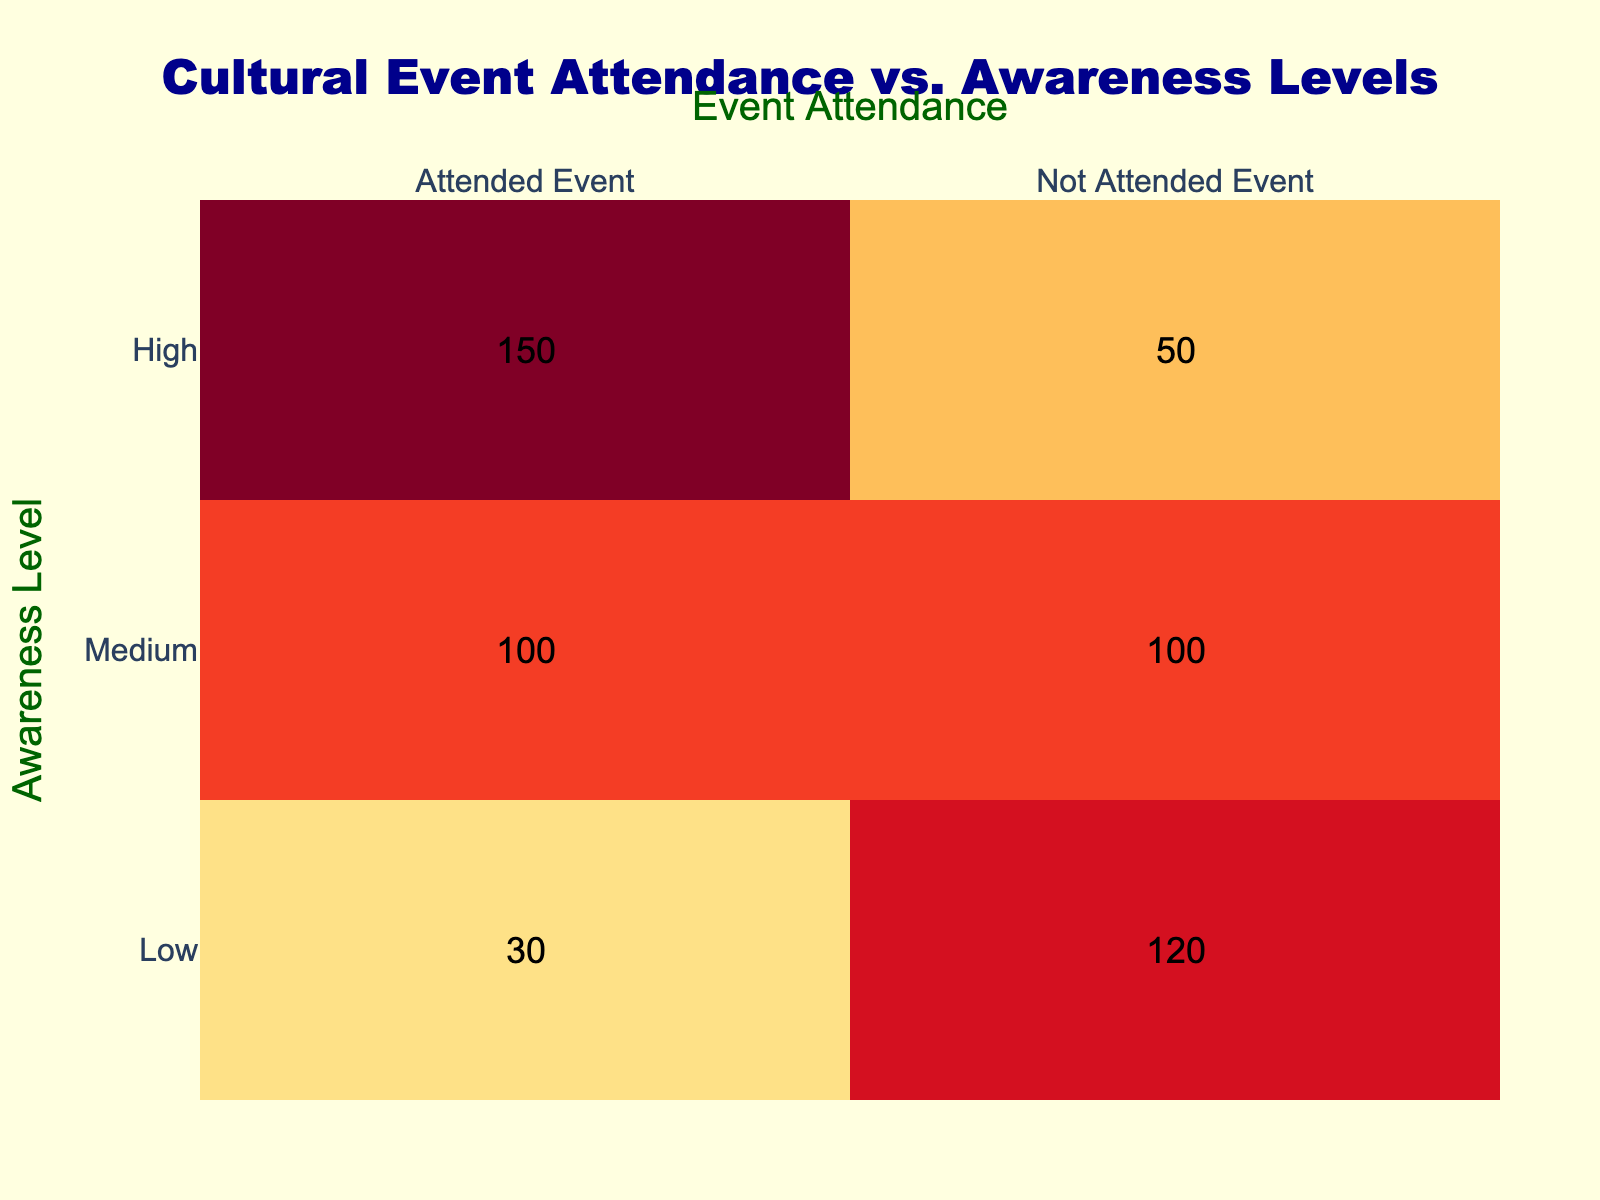What is the total number of individuals who attended cultural events? To find the total number of attendees, sum the values in the "Attended Event" column: 150 (High) + 100 (Medium) + 30 (Low) = 280.
Answer: 280 How many people with low awareness did not attend the event? From the table, the number of people with low awareness who did not attend the event is directly given as 120.
Answer: 120 What percentage of individuals with high awareness attended the event? To calculate the percentage, first identify the number of individuals with high awareness (150 attended, 50 did not). The total is 150 + 50 = 200. The percentage is (150/200) * 100 = 75%.
Answer: 75% Is it true that more individuals with medium awareness attended the event than those with low awareness? Compare the number of individuals who attended the event: 100 (Medium) vs 30 (Low). Since 100 is greater than 30, the statement is true.
Answer: Yes What is the difference in the number of attendees between high and medium awareness levels? The number of attendees for high awareness is 150 and for medium awareness is 100. The difference is 150 - 100 = 50.
Answer: 50 What is the total number of individuals who did not attend the event across all awareness levels? To find the total number of non-attendees, sum the values in the "Not Attended Event" column: 50 (High) + 100 (Medium) + 120 (Low) = 270.
Answer: 270 What proportion of attendees had low awareness? There are 30 individuals with low awareness who attended the event, out of a total of 280 attendees. The proportion is 30/280 = 0.107, or about 10.7%.
Answer: Approximately 10.7% Did the number of individuals with medium awareness who attended the event equal those with low awareness who did not attend? The number of people with medium awareness who attended is 100, while those with low awareness who did not attend is 120. Since 100 is not equal to 120, the statement is false.
Answer: No What is the average number of attendees for each awareness level? Calculate the average by adding the total attendees for all awareness levels (150 + 100 + 30) and dividing by the number of awareness levels (3): (150 + 100 + 30)/3 = 93.33.
Answer: 93.33 